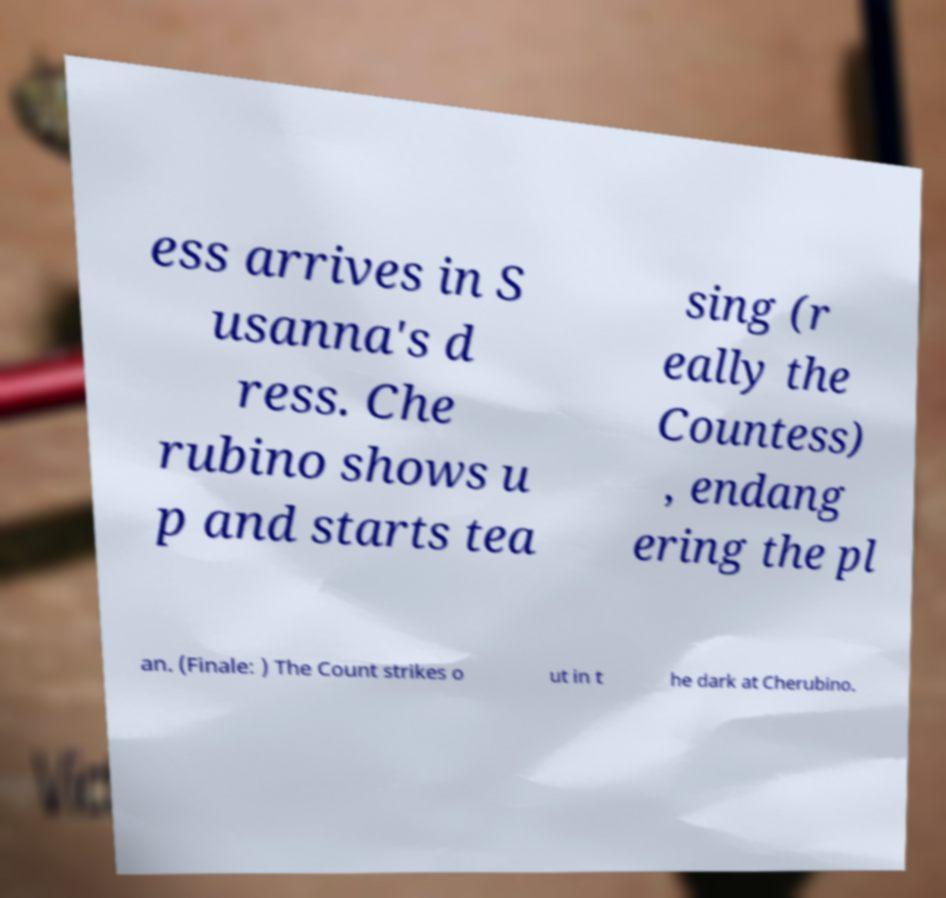I need the written content from this picture converted into text. Can you do that? ess arrives in S usanna's d ress. Che rubino shows u p and starts tea sing (r eally the Countess) , endang ering the pl an. (Finale: ) The Count strikes o ut in t he dark at Cherubino. 